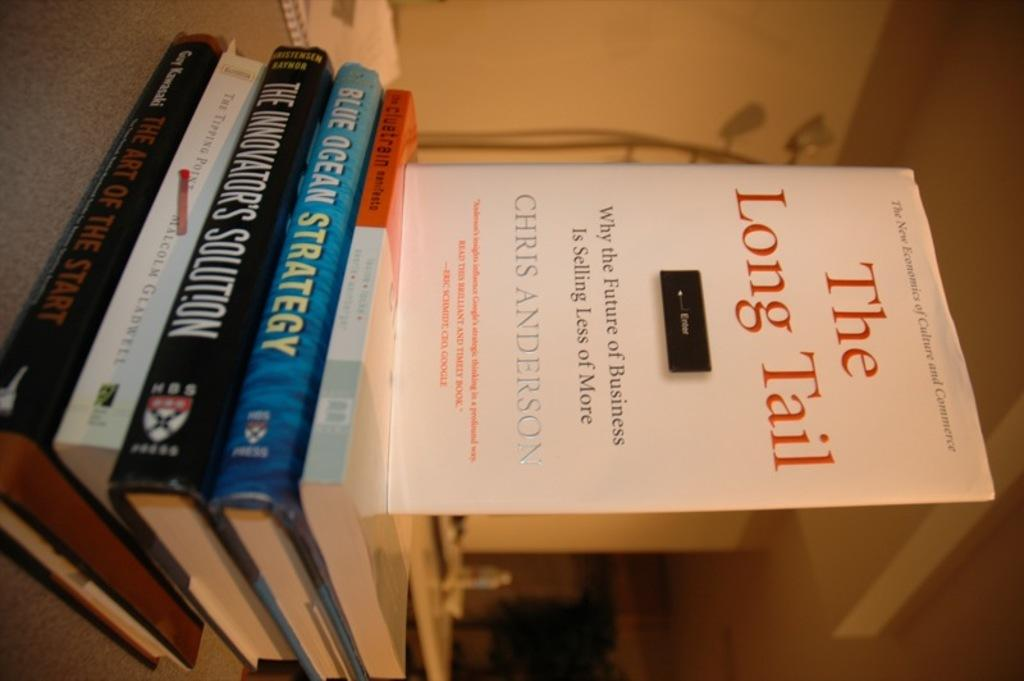<image>
Offer a succinct explanation of the picture presented. Several hard cover books about doing business from HBS Press. 